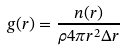Convert formula to latex. <formula><loc_0><loc_0><loc_500><loc_500>g ( r ) = \frac { n ( r ) } { \rho 4 \pi r ^ { 2 } \Delta r }</formula> 